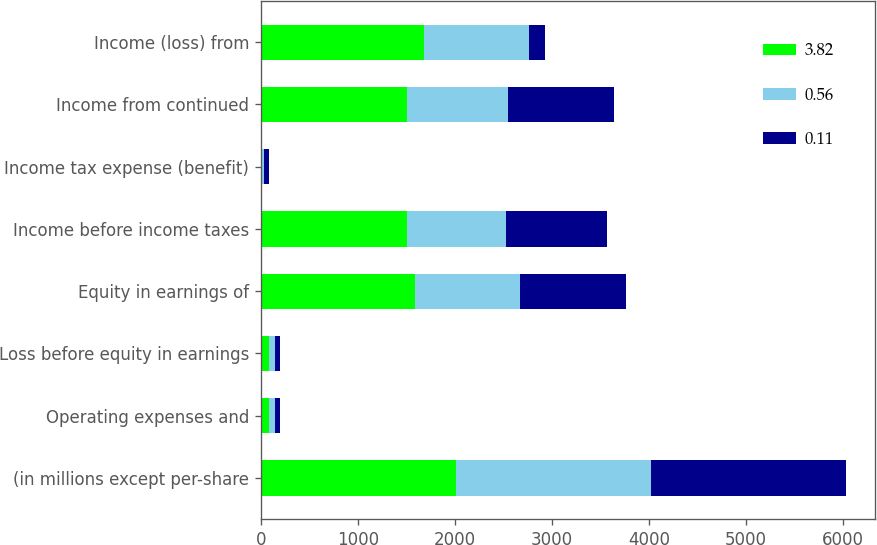Convert chart to OTSL. <chart><loc_0><loc_0><loc_500><loc_500><stacked_bar_chart><ecel><fcel>(in millions except per-share<fcel>Operating expenses and<fcel>Loss before equity in earnings<fcel>Equity in earnings of<fcel>Income before income taxes<fcel>Income tax expense (benefit)<fcel>Income from continued<fcel>Income (loss) from<nl><fcel>3.82<fcel>2012<fcel>80<fcel>80<fcel>1590<fcel>1510<fcel>7<fcel>1503<fcel>1686<nl><fcel>0.56<fcel>2011<fcel>63<fcel>63<fcel>1077<fcel>1014<fcel>27<fcel>1041<fcel>1078<nl><fcel>0.11<fcel>2010<fcel>56<fcel>56<fcel>1098<fcel>1042<fcel>50<fcel>1092<fcel>164<nl></chart> 